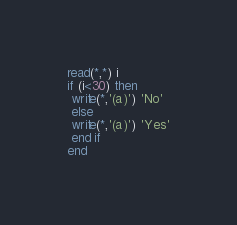<code> <loc_0><loc_0><loc_500><loc_500><_FORTRAN_>read(*,*) i
if (i<30) then
 write(*,'(a)') 'No'
 else 	
 write(*,'(a)') 'Yes'
 end if
end</code> 